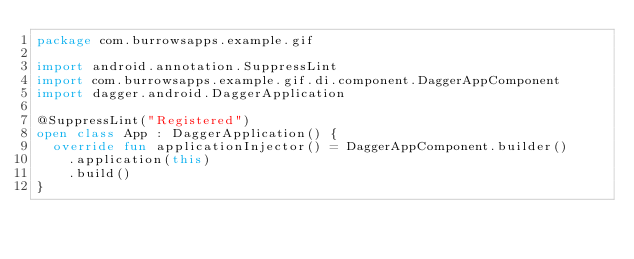<code> <loc_0><loc_0><loc_500><loc_500><_Kotlin_>package com.burrowsapps.example.gif

import android.annotation.SuppressLint
import com.burrowsapps.example.gif.di.component.DaggerAppComponent
import dagger.android.DaggerApplication

@SuppressLint("Registered")
open class App : DaggerApplication() {
  override fun applicationInjector() = DaggerAppComponent.builder()
    .application(this)
    .build()
}
</code> 